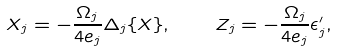Convert formula to latex. <formula><loc_0><loc_0><loc_500><loc_500>X _ { j } = - \frac { \Omega _ { j } } { 4 e _ { j } } \Delta _ { j } \{ X \} , \quad Z _ { j } = - \frac { \Omega _ { j } } { 4 e _ { j } } \epsilon _ { j } ^ { \prime } ,</formula> 